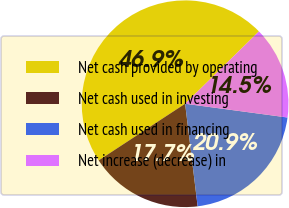Convert chart to OTSL. <chart><loc_0><loc_0><loc_500><loc_500><pie_chart><fcel>Net cash provided by operating<fcel>Net cash used in investing<fcel>Net cash used in financing<fcel>Net increase (decrease) in<nl><fcel>46.9%<fcel>17.7%<fcel>20.94%<fcel>14.46%<nl></chart> 